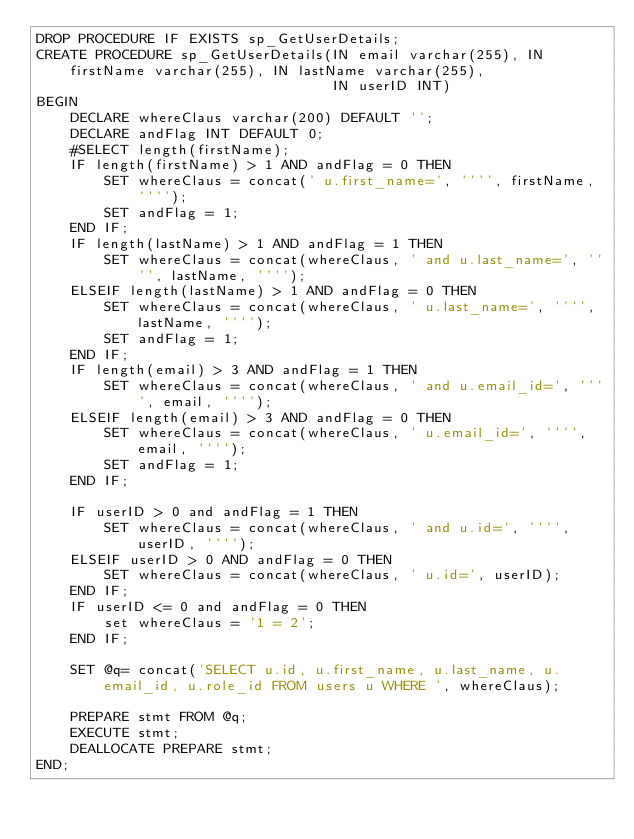<code> <loc_0><loc_0><loc_500><loc_500><_SQL_>DROP PROCEDURE IF EXISTS sp_GetUserDetails;
CREATE PROCEDURE sp_GetUserDetails(IN email varchar(255), IN firstName varchar(255), IN lastName varchar(255),
                                   IN userID INT)
BEGIN
    DECLARE whereClaus varchar(200) DEFAULT '';
    DECLARE andFlag INT DEFAULT 0;
    #SELECT length(firstName);
    IF length(firstName) > 1 AND andFlag = 0 THEN
        SET whereClaus = concat(' u.first_name=', '''', firstName, '''');
        SET andFlag = 1;
    END IF;
    IF length(lastName) > 1 AND andFlag = 1 THEN
        SET whereClaus = concat(whereClaus, ' and u.last_name=', '''', lastName, '''');
    ELSEIF length(lastName) > 1 AND andFlag = 0 THEN
        SET whereClaus = concat(whereClaus, ' u.last_name=', '''', lastName, '''');
        SET andFlag = 1;
    END IF;
    IF length(email) > 3 AND andFlag = 1 THEN
        SET whereClaus = concat(whereClaus, ' and u.email_id=', '''', email, '''');
    ELSEIF length(email) > 3 AND andFlag = 0 THEN
        SET whereClaus = concat(whereClaus, ' u.email_id=', '''', email, '''');
        SET andFlag = 1;
    END IF;

    IF userID > 0 and andFlag = 1 THEN
        SET whereClaus = concat(whereClaus, ' and u.id=', '''', userID, '''');
    ELSEIF userID > 0 AND andFlag = 0 THEN
        SET whereClaus = concat(whereClaus, ' u.id=', userID);
    END IF;
    IF userID <= 0 and andFlag = 0 THEN
        set whereClaus = '1 = 2';
    END IF;

    SET @q= concat('SELECT u.id, u.first_name, u.last_name, u.email_id, u.role_id FROM users u WHERE ', whereClaus);

    PREPARE stmt FROM @q;
    EXECUTE stmt;
    DEALLOCATE PREPARE stmt;
END;


</code> 